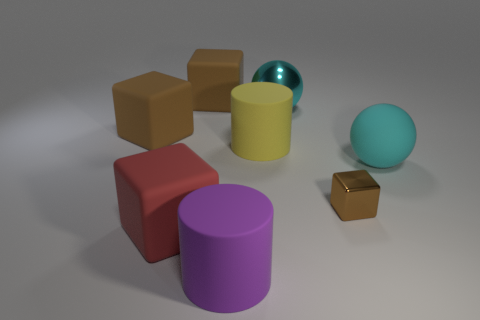Subtract all tiny blocks. How many blocks are left? 3 Subtract all cyan balls. How many brown blocks are left? 3 Subtract all red cubes. How many cubes are left? 3 Subtract all purple cubes. Subtract all gray spheres. How many cubes are left? 4 Add 2 shiny balls. How many objects exist? 10 Subtract all cylinders. How many objects are left? 6 Add 8 red matte blocks. How many red matte blocks are left? 9 Add 1 small brown things. How many small brown things exist? 2 Subtract 2 brown cubes. How many objects are left? 6 Subtract all big red matte things. Subtract all brown blocks. How many objects are left? 4 